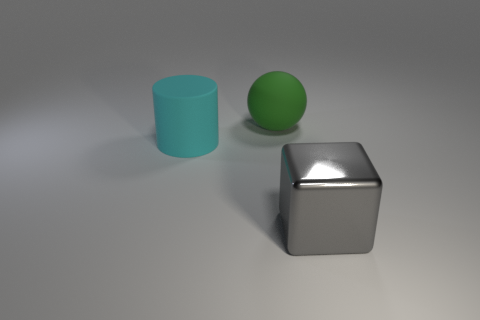Is there any other thing that has the same material as the gray object?
Ensure brevity in your answer.  No. Does the big green thing have the same material as the cyan thing?
Offer a terse response. Yes. What number of objects are things behind the large cube or big things to the right of the large cylinder?
Your answer should be very brief. 3. Is there a blue cylinder of the same size as the shiny thing?
Your answer should be compact. No. Is there a cube on the left side of the big matte thing to the right of the large cyan thing?
Provide a succinct answer. No. There is a rubber thing behind the large cyan rubber cylinder; does it have the same shape as the metal thing?
Your answer should be very brief. No. What is the shape of the big metallic thing?
Keep it short and to the point. Cube. What number of balls have the same material as the big green thing?
Your answer should be compact. 0. Do the large block and the object left of the green thing have the same color?
Ensure brevity in your answer.  No. What number of big rubber spheres are there?
Ensure brevity in your answer.  1. 